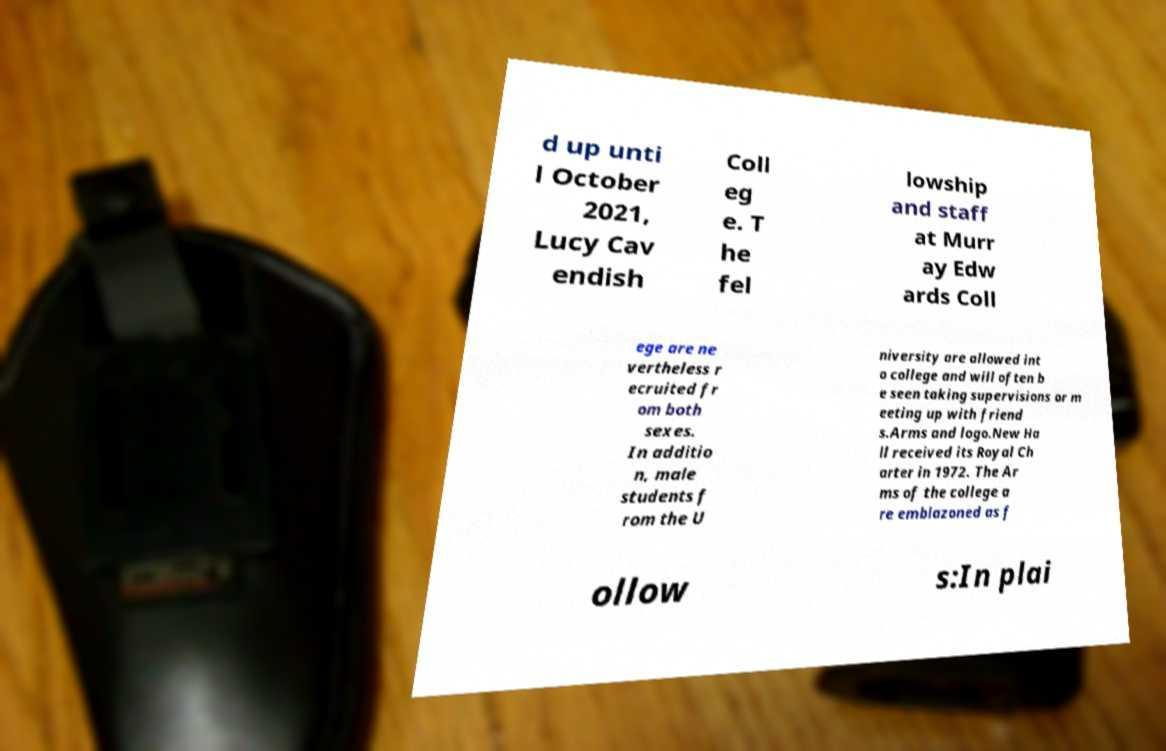There's text embedded in this image that I need extracted. Can you transcribe it verbatim? d up unti l October 2021, Lucy Cav endish Coll eg e. T he fel lowship and staff at Murr ay Edw ards Coll ege are ne vertheless r ecruited fr om both sexes. In additio n, male students f rom the U niversity are allowed int o college and will often b e seen taking supervisions or m eeting up with friend s.Arms and logo.New Ha ll received its Royal Ch arter in 1972. The Ar ms of the college a re emblazoned as f ollow s:In plai 